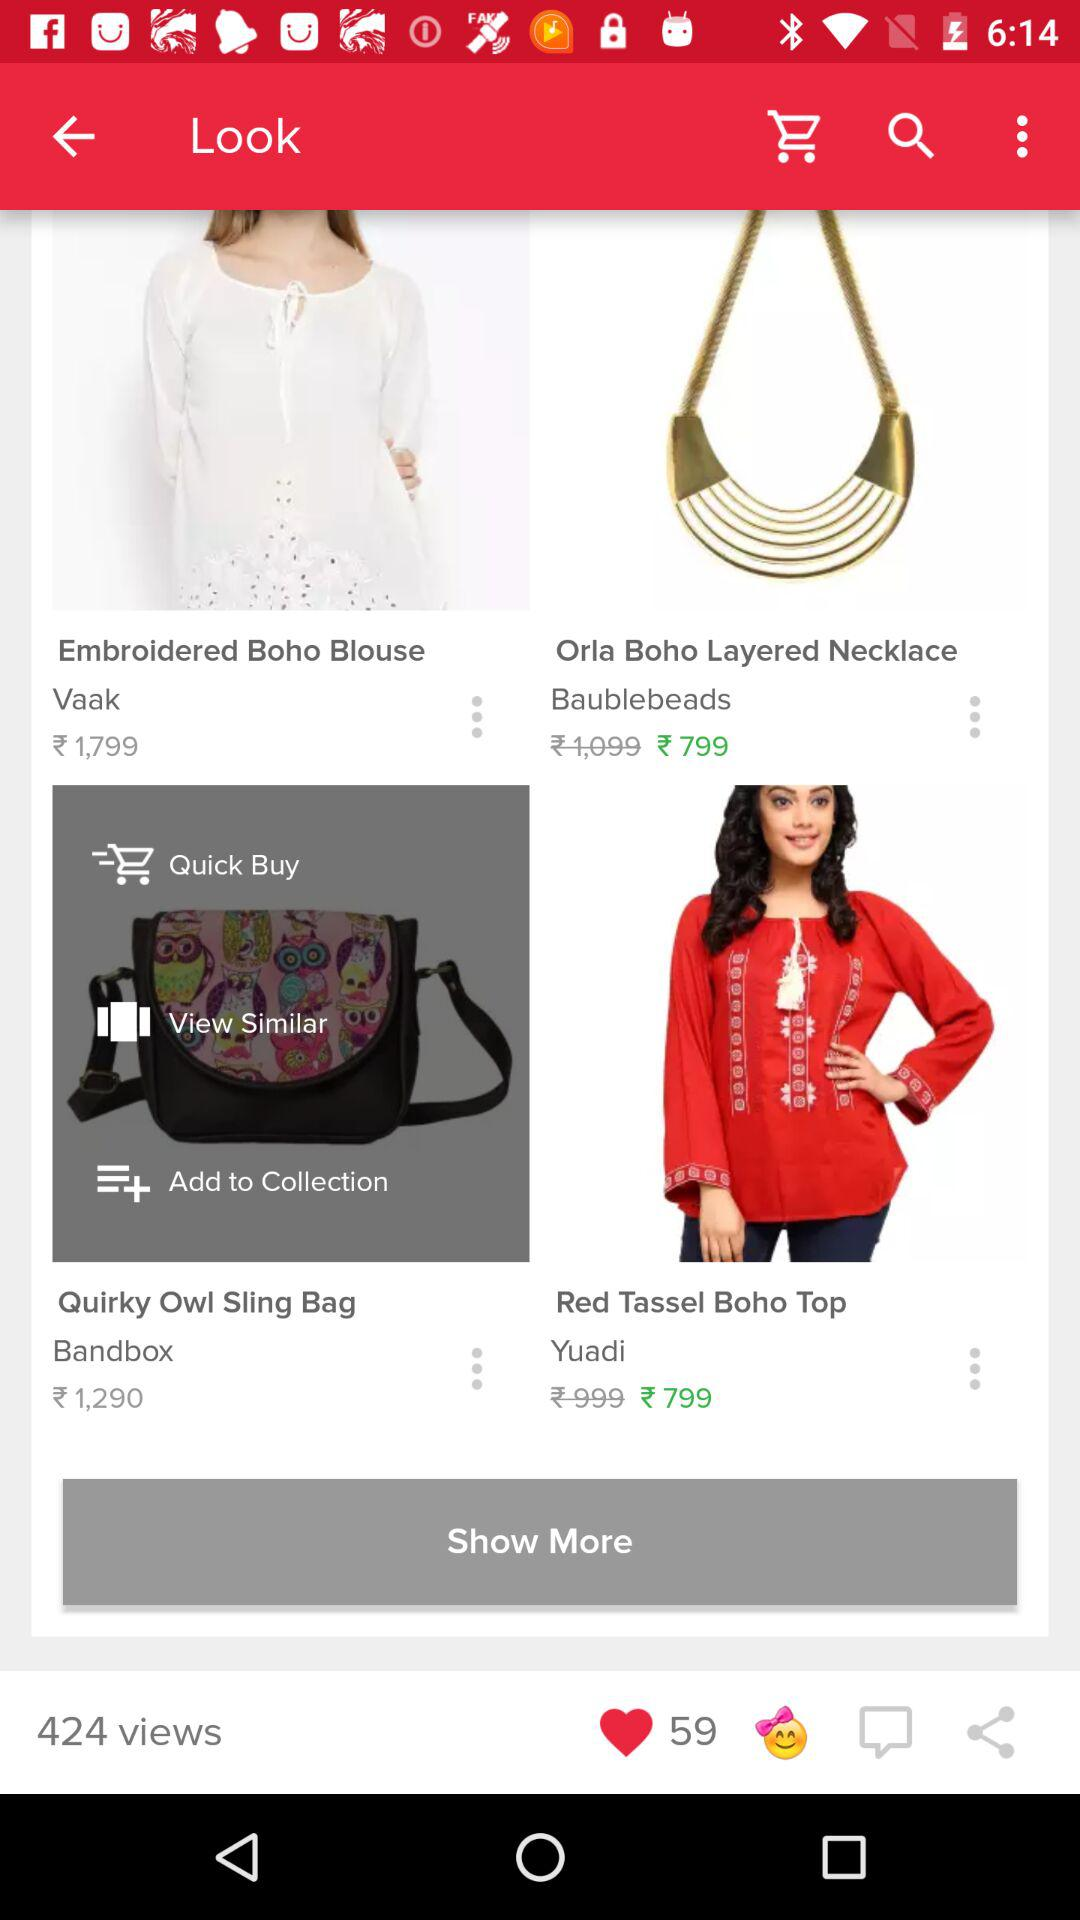What is the total number of views? The total number of views is 424. 